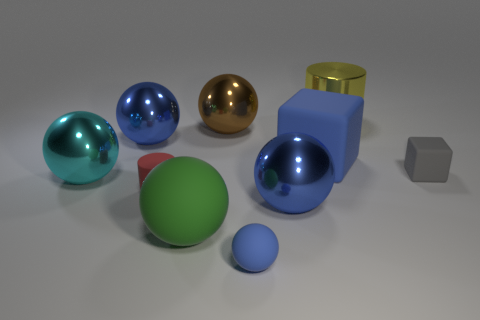What size is the matte object that is the same color as the big rubber block?
Give a very brief answer. Small. What number of cubes are the same color as the tiny matte ball?
Provide a succinct answer. 1. The blue metallic thing in front of the cyan thing has what shape?
Make the answer very short. Sphere. The small matte thing that is to the right of the blue matte object that is on the right side of the big blue metal object that is in front of the rubber cylinder is what shape?
Provide a short and direct response. Cube. How many things are either large blocks or blue objects?
Your answer should be very brief. 4. Does the big matte thing left of the big block have the same shape as the big blue metallic object that is to the right of the tiny red cylinder?
Give a very brief answer. Yes. What number of blocks are in front of the large blue matte cube and left of the gray cube?
Give a very brief answer. 0. What number of other objects are there of the same size as the red matte cylinder?
Make the answer very short. 2. What material is the big blue thing that is behind the red matte cylinder and right of the small blue thing?
Provide a succinct answer. Rubber. There is a tiny matte sphere; is it the same color as the large matte object right of the brown object?
Offer a terse response. Yes. 